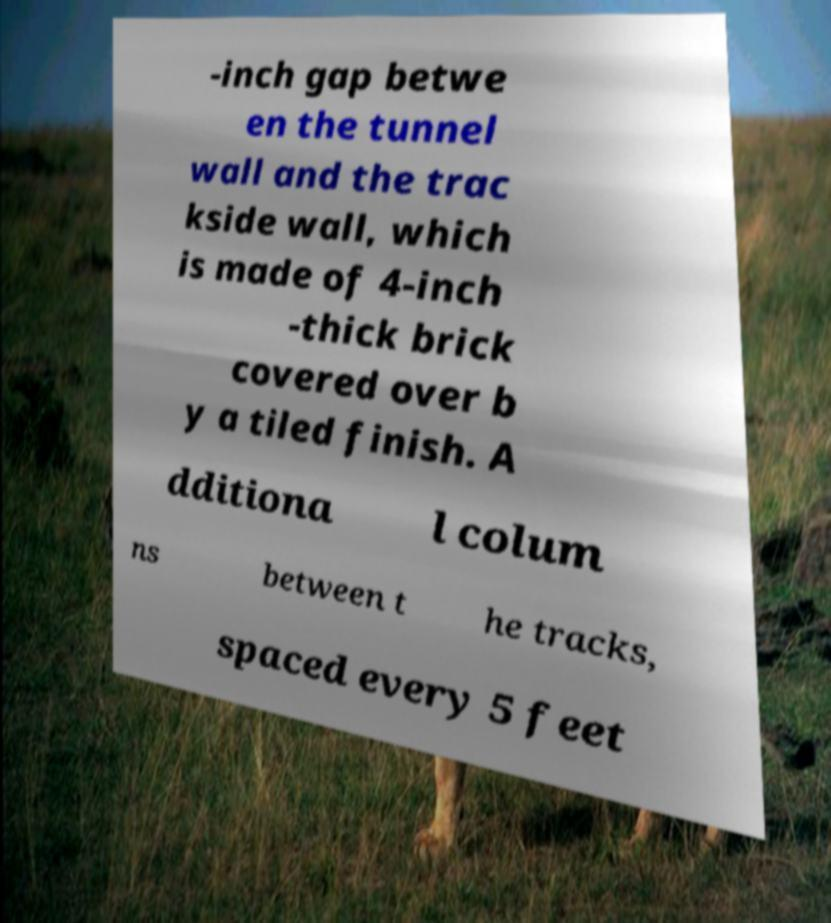Could you extract and type out the text from this image? -inch gap betwe en the tunnel wall and the trac kside wall, which is made of 4-inch -thick brick covered over b y a tiled finish. A dditiona l colum ns between t he tracks, spaced every 5 feet 